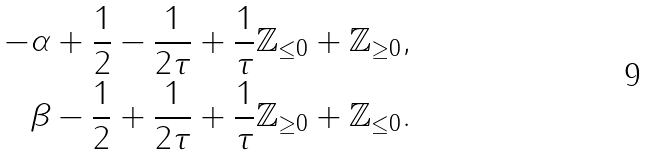Convert formula to latex. <formula><loc_0><loc_0><loc_500><loc_500>- & \alpha + \frac { 1 } { 2 } - \frac { 1 } { 2 \tau } + \frac { 1 } { \tau } \mathbb { Z } _ { \leq 0 } + \mathbb { Z } _ { \geq 0 } , \\ & \beta - \frac { 1 } { 2 } + \frac { 1 } { 2 \tau } + \frac { 1 } { \tau } \mathbb { Z } _ { \geq 0 } + \mathbb { Z } _ { \leq 0 } .</formula> 